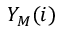<formula> <loc_0><loc_0><loc_500><loc_500>Y _ { M } ( i )</formula> 